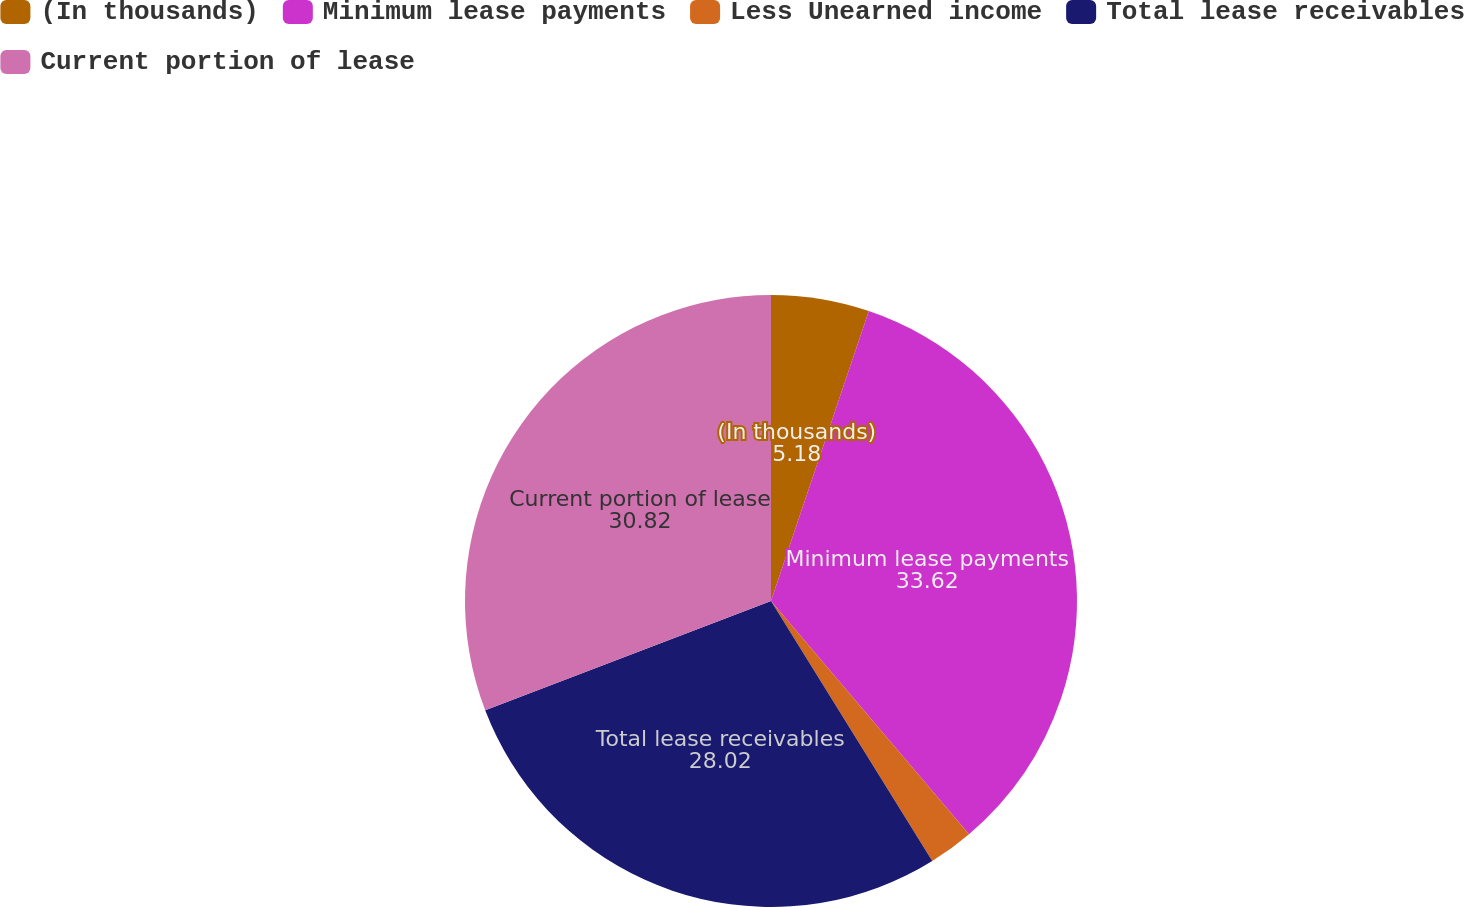<chart> <loc_0><loc_0><loc_500><loc_500><pie_chart><fcel>(In thousands)<fcel>Minimum lease payments<fcel>Less Unearned income<fcel>Total lease receivables<fcel>Current portion of lease<nl><fcel>5.18%<fcel>33.62%<fcel>2.37%<fcel>28.02%<fcel>30.82%<nl></chart> 